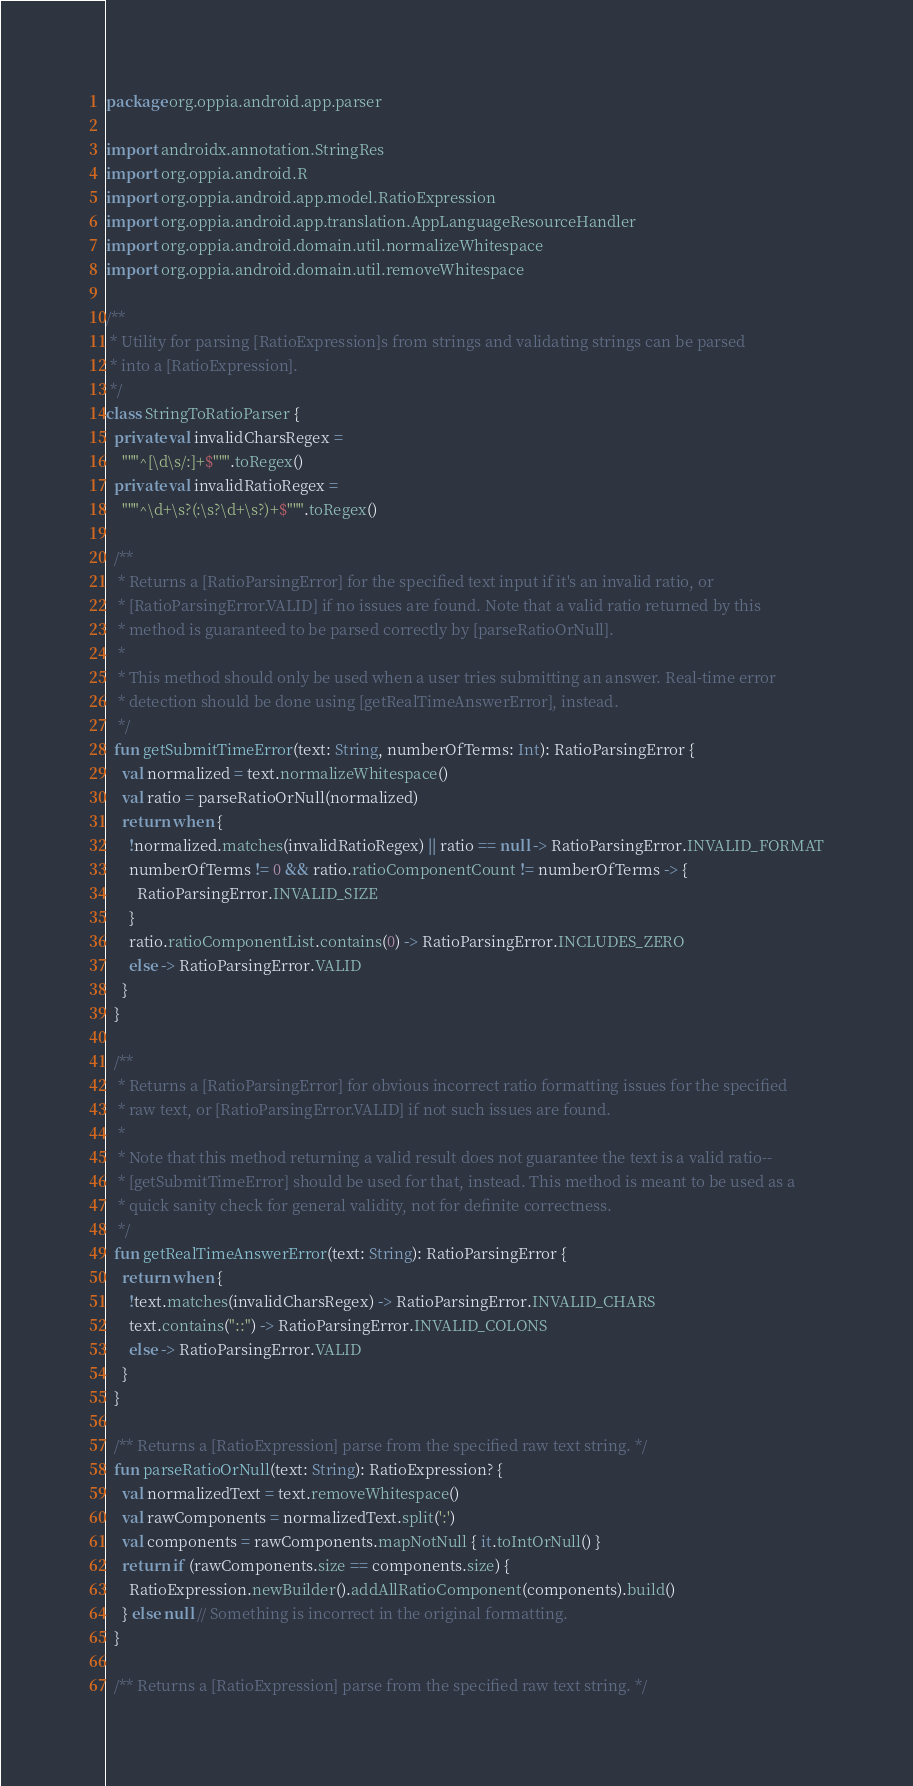<code> <loc_0><loc_0><loc_500><loc_500><_Kotlin_>package org.oppia.android.app.parser

import androidx.annotation.StringRes
import org.oppia.android.R
import org.oppia.android.app.model.RatioExpression
import org.oppia.android.app.translation.AppLanguageResourceHandler
import org.oppia.android.domain.util.normalizeWhitespace
import org.oppia.android.domain.util.removeWhitespace

/**
 * Utility for parsing [RatioExpression]s from strings and validating strings can be parsed
 * into a [RatioExpression].
 */
class StringToRatioParser {
  private val invalidCharsRegex =
    """^[\d\s/:]+$""".toRegex()
  private val invalidRatioRegex =
    """^\d+\s?(:\s?\d+\s?)+$""".toRegex()

  /**
   * Returns a [RatioParsingError] for the specified text input if it's an invalid ratio, or
   * [RatioParsingError.VALID] if no issues are found. Note that a valid ratio returned by this
   * method is guaranteed to be parsed correctly by [parseRatioOrNull].
   *
   * This method should only be used when a user tries submitting an answer. Real-time error
   * detection should be done using [getRealTimeAnswerError], instead.
   */
  fun getSubmitTimeError(text: String, numberOfTerms: Int): RatioParsingError {
    val normalized = text.normalizeWhitespace()
    val ratio = parseRatioOrNull(normalized)
    return when {
      !normalized.matches(invalidRatioRegex) || ratio == null -> RatioParsingError.INVALID_FORMAT
      numberOfTerms != 0 && ratio.ratioComponentCount != numberOfTerms -> {
        RatioParsingError.INVALID_SIZE
      }
      ratio.ratioComponentList.contains(0) -> RatioParsingError.INCLUDES_ZERO
      else -> RatioParsingError.VALID
    }
  }

  /**
   * Returns a [RatioParsingError] for obvious incorrect ratio formatting issues for the specified
   * raw text, or [RatioParsingError.VALID] if not such issues are found.
   *
   * Note that this method returning a valid result does not guarantee the text is a valid ratio--
   * [getSubmitTimeError] should be used for that, instead. This method is meant to be used as a
   * quick sanity check for general validity, not for definite correctness.
   */
  fun getRealTimeAnswerError(text: String): RatioParsingError {
    return when {
      !text.matches(invalidCharsRegex) -> RatioParsingError.INVALID_CHARS
      text.contains("::") -> RatioParsingError.INVALID_COLONS
      else -> RatioParsingError.VALID
    }
  }

  /** Returns a [RatioExpression] parse from the specified raw text string. */
  fun parseRatioOrNull(text: String): RatioExpression? {
    val normalizedText = text.removeWhitespace()
    val rawComponents = normalizedText.split(':')
    val components = rawComponents.mapNotNull { it.toIntOrNull() }
    return if (rawComponents.size == components.size) {
      RatioExpression.newBuilder().addAllRatioComponent(components).build()
    } else null // Something is incorrect in the original formatting.
  }

  /** Returns a [RatioExpression] parse from the specified raw text string. */</code> 